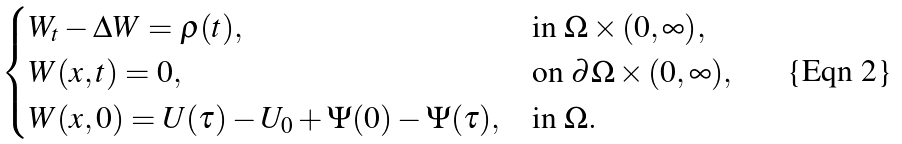Convert formula to latex. <formula><loc_0><loc_0><loc_500><loc_500>\begin{cases} W _ { t } - \Delta W = \varrho ( t ) , & \text {in $\Omega\times(0,\infty)$} , \\ W ( x , t ) = 0 , & \text {on $\partial\Omega\times(0,\infty)$} , \\ W ( x , 0 ) = U ( \tau ) - U _ { 0 } + \Psi ( 0 ) - \Psi ( \tau ) , & \text {in $\Omega$} . \end{cases}</formula> 